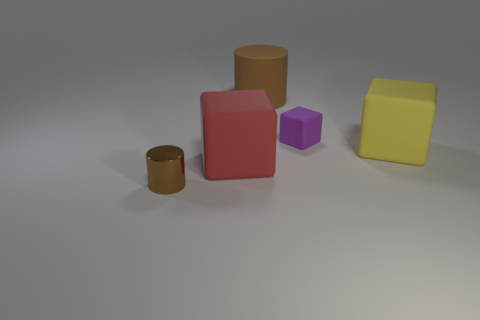Is there a large red rubber object that is in front of the block behind the yellow thing?
Your answer should be compact. Yes. There is a tiny object that is in front of the tiny matte object; what material is it?
Your response must be concise. Metal. Is the material of the small thing that is behind the yellow rubber object the same as the big cube in front of the big yellow object?
Provide a succinct answer. Yes. Is the number of yellow things that are in front of the red matte thing the same as the number of big yellow cubes that are behind the matte cylinder?
Offer a very short reply. Yes. What number of cylinders have the same material as the purple object?
Provide a succinct answer. 1. There is a brown cylinder that is on the left side of the brown cylinder behind the large red cube; how big is it?
Offer a terse response. Small. Does the small thing behind the red matte block have the same shape as the brown thing in front of the tiny purple matte cube?
Your response must be concise. No. Are there the same number of yellow matte objects that are left of the small brown metallic thing and green blocks?
Give a very brief answer. Yes. What is the color of the other large object that is the same shape as the big red matte thing?
Offer a terse response. Yellow. Is the material of the cylinder that is behind the yellow thing the same as the red object?
Offer a terse response. Yes. 